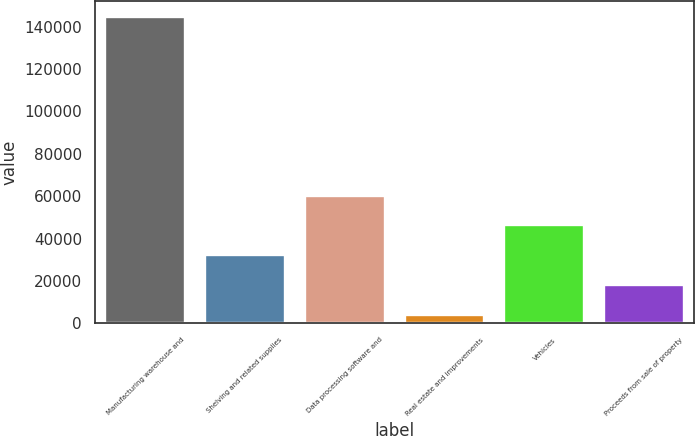Convert chart to OTSL. <chart><loc_0><loc_0><loc_500><loc_500><bar_chart><fcel>Manufacturing warehouse and<fcel>Shelving and related supplies<fcel>Data processing software and<fcel>Real estate and improvements<fcel>Vehicles<fcel>Proceeds from sale of property<nl><fcel>144649<fcel>32202.6<fcel>60314.2<fcel>4091<fcel>46258.4<fcel>18146.8<nl></chart> 